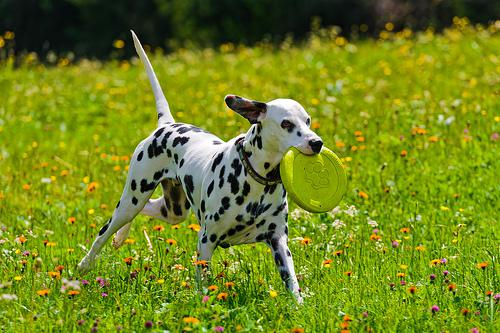Question: what kind of animal is in the photo?
Choices:
A. Frog.
B. A dog.
C. Cat.
D. Raccoon.
Answer with the letter. Answer: B Question: what colors are the flowers?
Choices:
A. Red.
B. Blue.
C. Orange, purple and yellow.
D. Green.
Answer with the letter. Answer: C Question: what type of dog is in the photo?
Choices:
A. Pug.
B. Poodle.
C. Hound.
D. A dalmatian.
Answer with the letter. Answer: D Question: what is in the background?
Choices:
A. Trees.
B. House.
C. Flowers and grass.
D. Beach.
Answer with the letter. Answer: C Question: what is in the dog's mouth?
Choices:
A. A frisbee.
B. A ball.
C. A bone.
D. A rope.
Answer with the letter. Answer: A Question: who is holding the frisbee?
Choices:
A. The man.
B. The woman.
C. The kid.
D. The dog.
Answer with the letter. Answer: D Question: where was this photo taken?
Choices:
A. In a field.
B. North Dallas.
C. South forty.
D. Manhattan Island.
Answer with the letter. Answer: A 